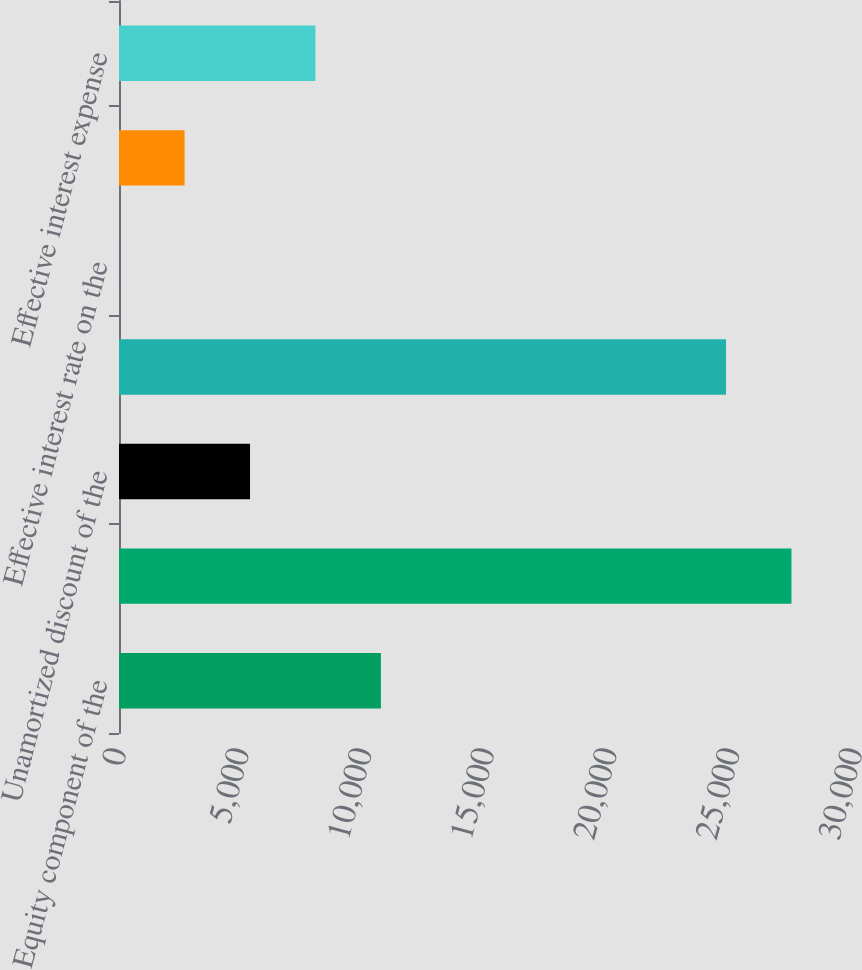Convert chart to OTSL. <chart><loc_0><loc_0><loc_500><loc_500><bar_chart><fcel>Equity component of the<fcel>Principal amount of the<fcel>Unamortized discount of the<fcel>Net carrying amount of the<fcel>Effective interest rate on the<fcel>Cash interest expense<fcel>Effective interest expense<nl><fcel>10674.9<fcel>27410<fcel>5340.88<fcel>24743<fcel>6.86<fcel>2673.87<fcel>8007.89<nl></chart> 